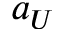<formula> <loc_0><loc_0><loc_500><loc_500>a _ { U }</formula> 